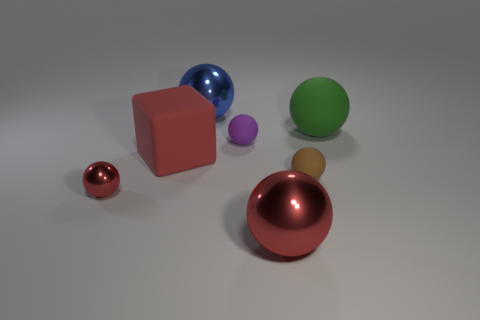Does the object that is behind the large green ball have the same color as the matte block? no 